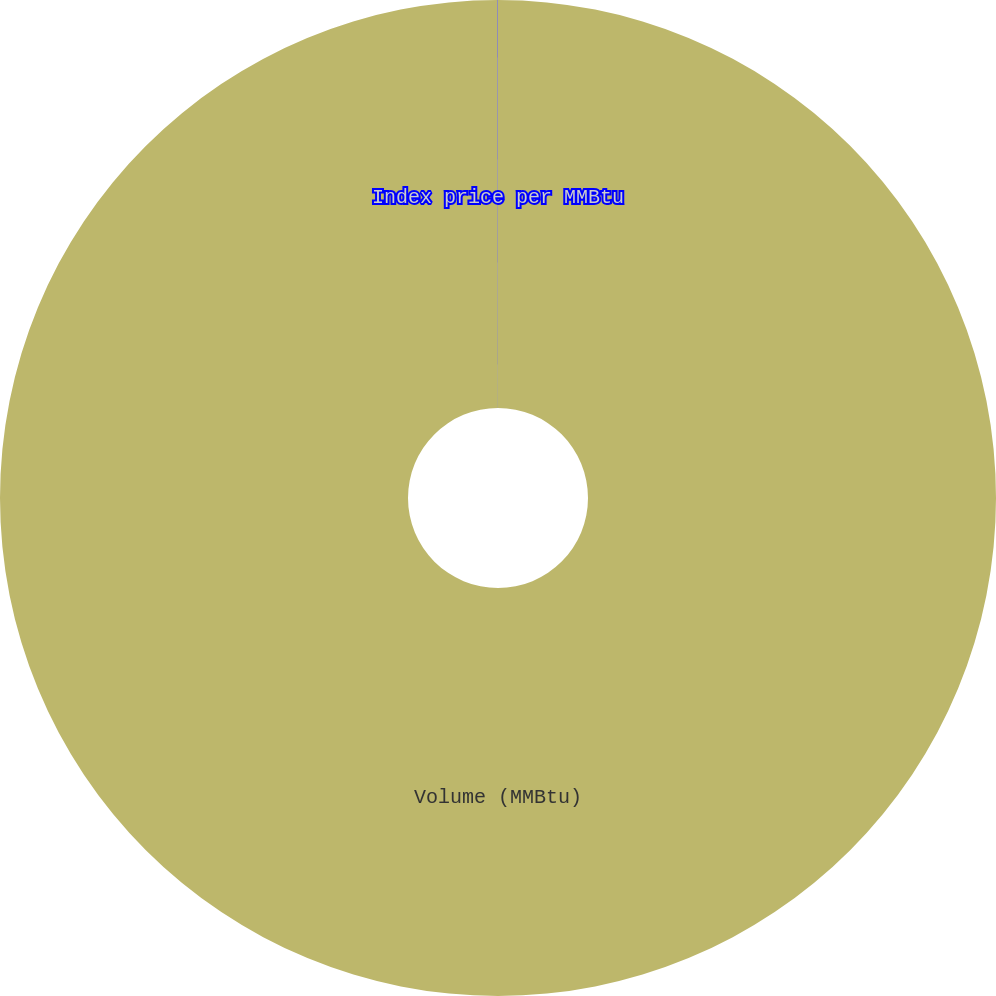Convert chart. <chart><loc_0><loc_0><loc_500><loc_500><pie_chart><fcel>Volume (MMBtu)<fcel>Index price per MMBtu<nl><fcel>99.99%<fcel>0.01%<nl></chart> 